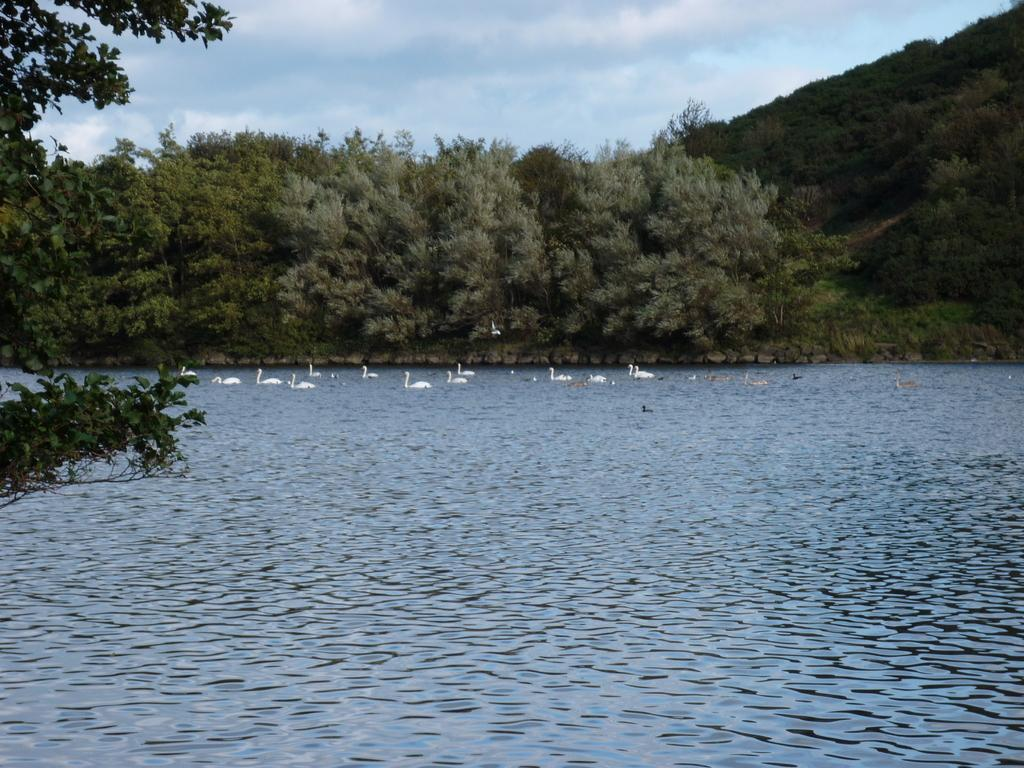What animals can be seen in the image? There are birds on the water in the image. What type of vegetation is visible in the image? There are trees visible in the image. What geographical feature is present in the image? There is a hill in the image. What is visible in the background of the image? The sky is visible in the background of the image. What type of veil is being worn by the bird in the image? There is no veil present in the image, as it features birds on the water and birds do not wear veils. 